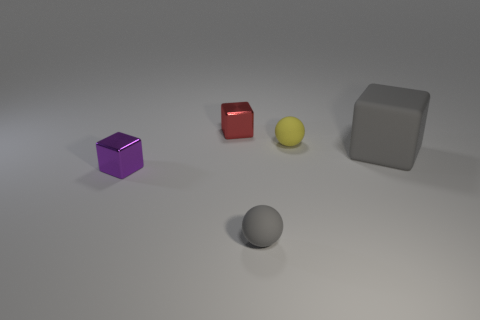Is the material of the sphere to the left of the tiny yellow thing the same as the cube that is in front of the big rubber cube?
Make the answer very short. No. How many spheres are behind the purple metal cube?
Your answer should be compact. 1. What number of red objects are either rubber cubes or small matte spheres?
Provide a short and direct response. 0. What is the material of the other ball that is the same size as the yellow sphere?
Make the answer very short. Rubber. There is a object that is on the left side of the tiny yellow sphere and behind the big gray rubber block; what is its shape?
Offer a very short reply. Cube. What is the color of the matte thing that is the same size as the yellow matte ball?
Your answer should be very brief. Gray. There is a block behind the big gray object; is it the same size as the matte ball that is right of the gray sphere?
Offer a very short reply. Yes. What size is the rubber object right of the small object to the right of the matte sphere that is left of the tiny yellow object?
Make the answer very short. Large. What shape is the gray thing that is to the right of the gray rubber thing in front of the large gray matte object?
Provide a succinct answer. Cube. There is a small matte sphere that is in front of the big block; is it the same color as the large thing?
Make the answer very short. Yes. 